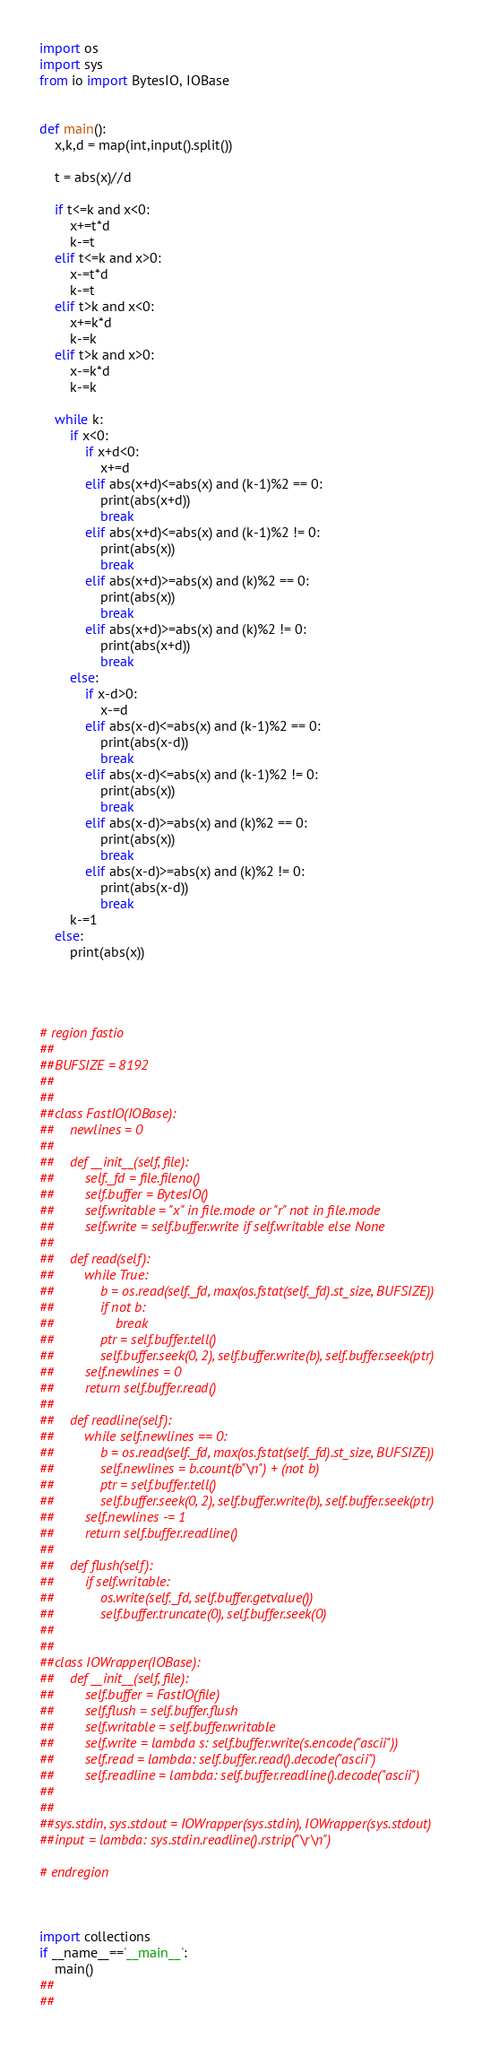Convert code to text. <code><loc_0><loc_0><loc_500><loc_500><_Python_>import os
import sys
from io import BytesIO, IOBase


def main():
    x,k,d = map(int,input().split())
    
    t = abs(x)//d
    
    if t<=k and x<0:
        x+=t*d
        k-=t
    elif t<=k and x>0:
        x-=t*d
        k-=t
    elif t>k and x<0:
        x+=k*d
        k-=k
    elif t>k and x>0:
        x-=k*d
        k-=k
    
    while k:
        if x<0:
            if x+d<0:
                x+=d
            elif abs(x+d)<=abs(x) and (k-1)%2 == 0:
                print(abs(x+d))
                break
            elif abs(x+d)<=abs(x) and (k-1)%2 != 0:
                print(abs(x))
                break
            elif abs(x+d)>=abs(x) and (k)%2 == 0:
                print(abs(x))
                break
            elif abs(x+d)>=abs(x) and (k)%2 != 0:
                print(abs(x+d))
                break
        else:
            if x-d>0:
                x-=d
            elif abs(x-d)<=abs(x) and (k-1)%2 == 0:
                print(abs(x-d))
                break
            elif abs(x-d)<=abs(x) and (k-1)%2 != 0:
                print(abs(x))
                break
            elif abs(x-d)>=abs(x) and (k)%2 == 0:
                print(abs(x))
                break
            elif abs(x-d)>=abs(x) and (k)%2 != 0:
                print(abs(x-d))
                break
        k-=1
    else:
        print(abs(x))
            
        
    

# region fastio
##
##BUFSIZE = 8192
##
##
##class FastIO(IOBase):
##    newlines = 0
##
##    def __init__(self, file):
##        self._fd = file.fileno()
##        self.buffer = BytesIO()
##        self.writable = "x" in file.mode or "r" not in file.mode
##        self.write = self.buffer.write if self.writable else None
##
##    def read(self):
##        while True:
##            b = os.read(self._fd, max(os.fstat(self._fd).st_size, BUFSIZE))
##            if not b:
##                break
##            ptr = self.buffer.tell()
##            self.buffer.seek(0, 2), self.buffer.write(b), self.buffer.seek(ptr)
##        self.newlines = 0
##        return self.buffer.read()
##
##    def readline(self):
##        while self.newlines == 0:
##            b = os.read(self._fd, max(os.fstat(self._fd).st_size, BUFSIZE))
##            self.newlines = b.count(b"\n") + (not b)
##            ptr = self.buffer.tell()
##            self.buffer.seek(0, 2), self.buffer.write(b), self.buffer.seek(ptr)
##        self.newlines -= 1
##        return self.buffer.readline()
##
##    def flush(self):
##        if self.writable:
##            os.write(self._fd, self.buffer.getvalue())
##            self.buffer.truncate(0), self.buffer.seek(0)
##
##
##class IOWrapper(IOBase):
##    def __init__(self, file):
##        self.buffer = FastIO(file)
##        self.flush = self.buffer.flush
##        self.writable = self.buffer.writable
##        self.write = lambda s: self.buffer.write(s.encode("ascii"))
##        self.read = lambda: self.buffer.read().decode("ascii")
##        self.readline = lambda: self.buffer.readline().decode("ascii")
##
##
##sys.stdin, sys.stdout = IOWrapper(sys.stdin), IOWrapper(sys.stdout)
##input = lambda: sys.stdin.readline().rstrip("\r\n")

# endregion



import collections
if __name__=='__main__':
    main()
##    
##                    
</code> 